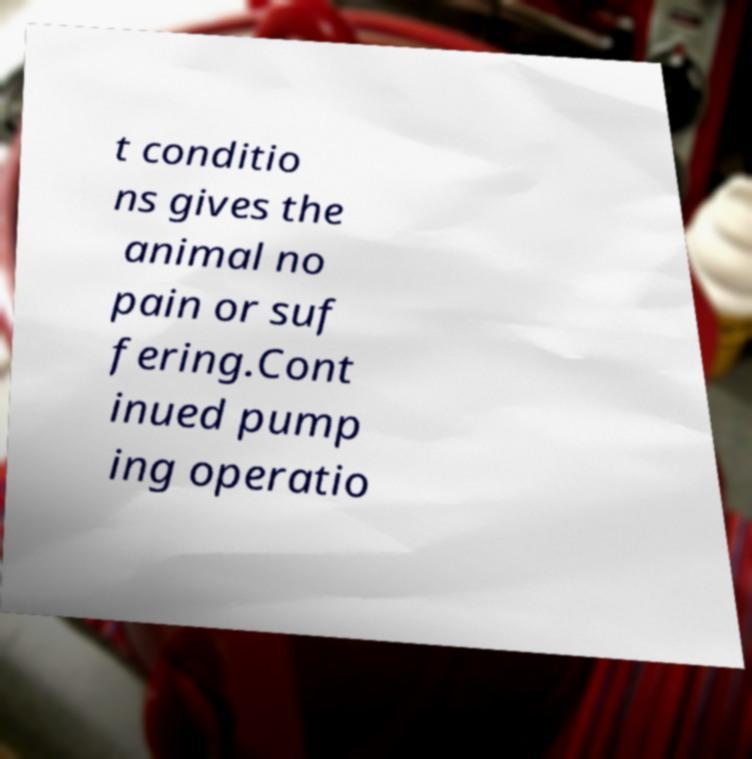There's text embedded in this image that I need extracted. Can you transcribe it verbatim? t conditio ns gives the animal no pain or suf fering.Cont inued pump ing operatio 